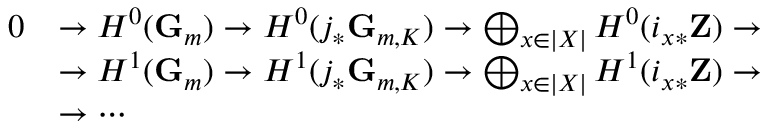<formula> <loc_0><loc_0><loc_500><loc_500>{ \begin{array} { r l } { 0 } & { \to H ^ { 0 } ( G _ { m } ) \to H ^ { 0 } ( j _ { * } G _ { m , K } ) \to \bigoplus _ { x \in | X | } H ^ { 0 } ( i _ { x * } Z ) \to } \\ & { \to H ^ { 1 } ( G _ { m } ) \to H ^ { 1 } ( j _ { * } G _ { m , K } ) \to \bigoplus _ { x \in | X | } H ^ { 1 } ( i _ { x * } Z ) \to } \\ & { \to \cdots } \end{array} }</formula> 